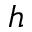<formula> <loc_0><loc_0><loc_500><loc_500>h</formula> 